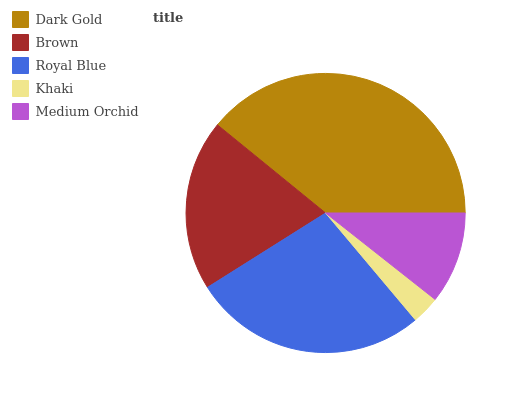Is Khaki the minimum?
Answer yes or no. Yes. Is Dark Gold the maximum?
Answer yes or no. Yes. Is Brown the minimum?
Answer yes or no. No. Is Brown the maximum?
Answer yes or no. No. Is Dark Gold greater than Brown?
Answer yes or no. Yes. Is Brown less than Dark Gold?
Answer yes or no. Yes. Is Brown greater than Dark Gold?
Answer yes or no. No. Is Dark Gold less than Brown?
Answer yes or no. No. Is Brown the high median?
Answer yes or no. Yes. Is Brown the low median?
Answer yes or no. Yes. Is Dark Gold the high median?
Answer yes or no. No. Is Medium Orchid the low median?
Answer yes or no. No. 